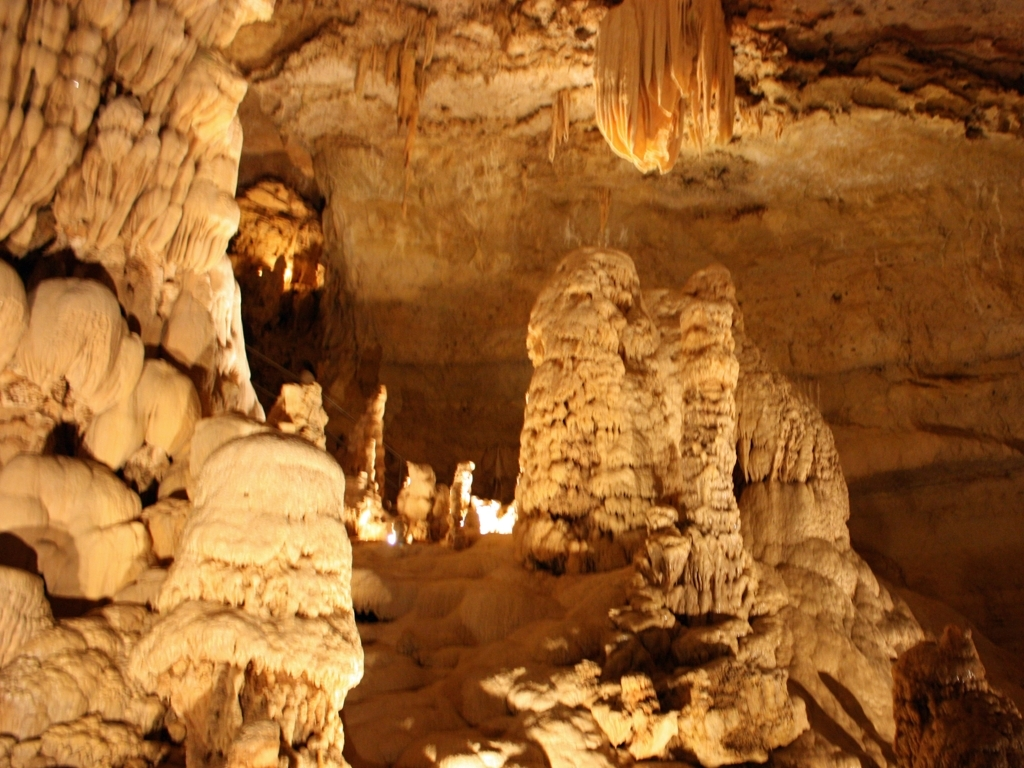What is the overall clarity of the image?
A. Average
B. Excellent
C. Outstanding The overall clarity of the image is considered average due to the visible blur and lack of sharpness in certain areas. While the lighting does highlight some features of the cave formation, the details are not captured with high precision, resulting in a rating of 'Average' for image clarity. 